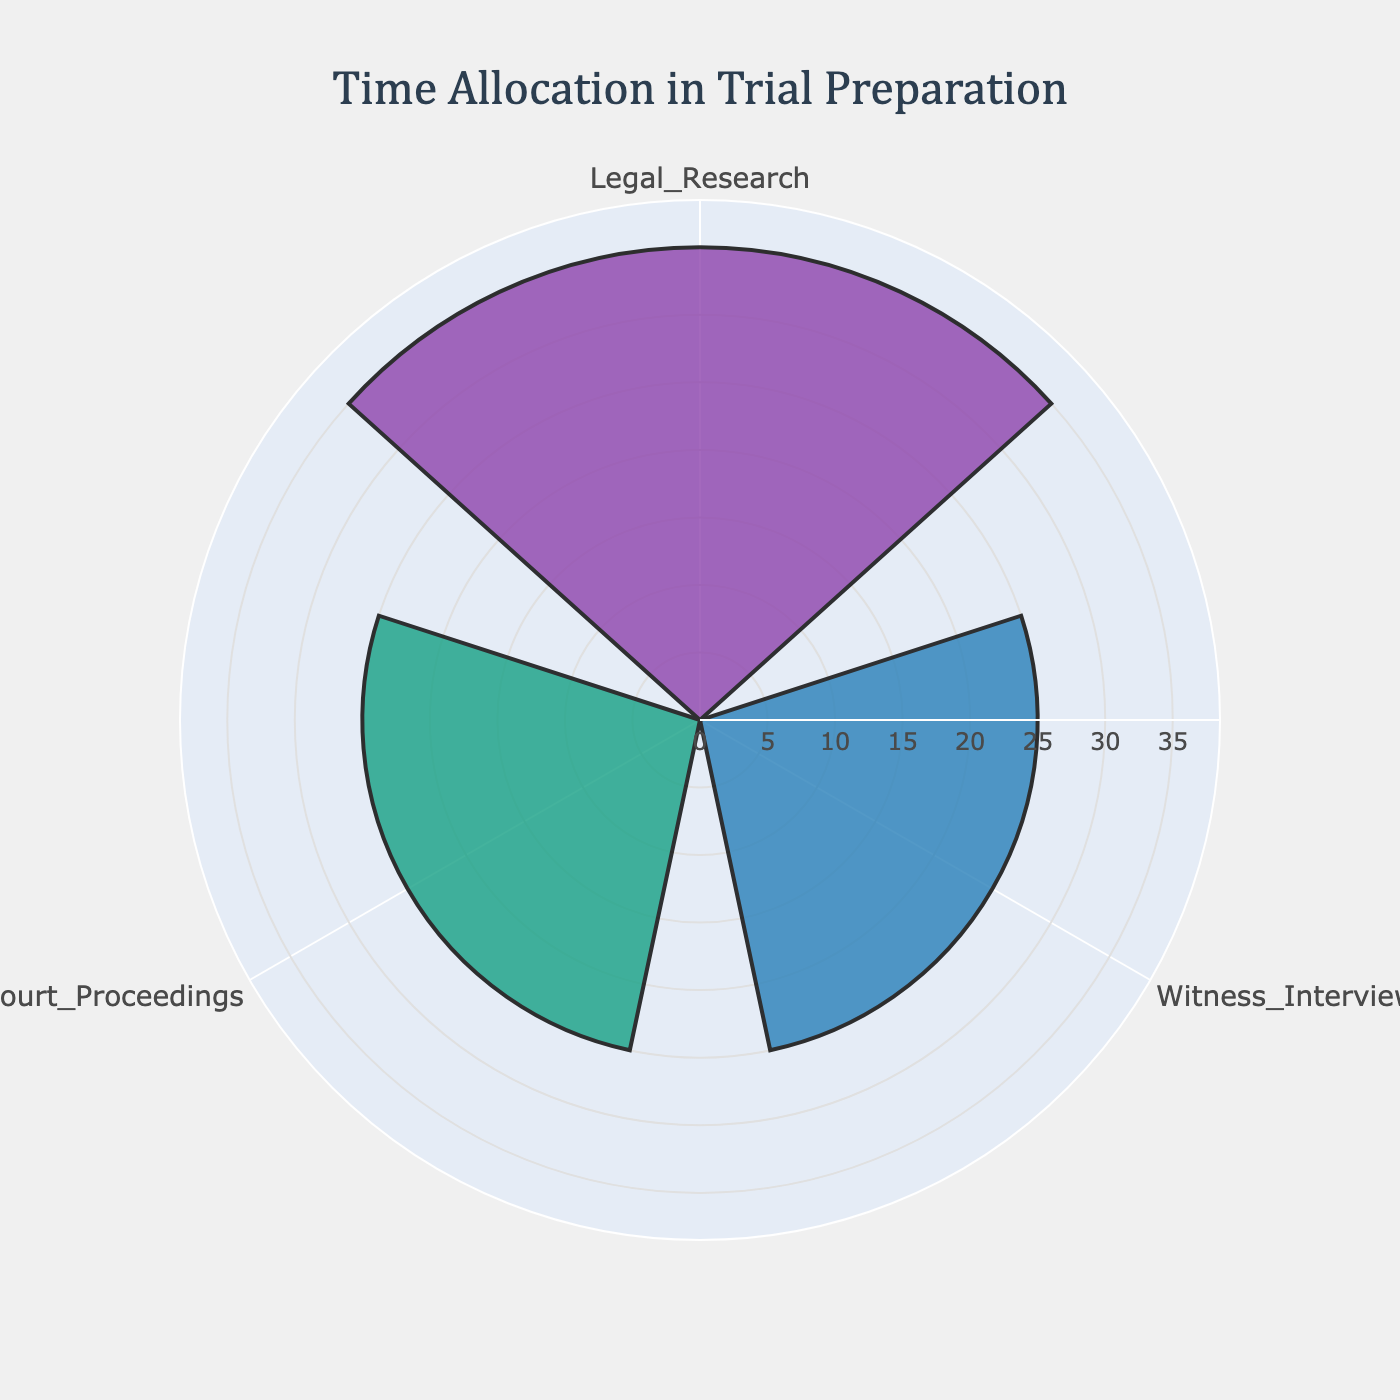What's the title of the chart? The title is usually displayed at the top of the chart to provide a brief summary of what the chart is about. The title on this chart reads "Time Allocation in Trial Preparation."
Answer: Time Allocation in Trial Preparation What are the three stages listed in the chart? The stages are labeled around the circular axis of the rose chart. They are "Legal Research," "Witness Interviews," and "Court Proceedings."
Answer: Legal Research, Witness Interviews, Court Proceedings Which stage has the highest percentage of time spent? By observing the lengths of the bars, the longest bar represents "Legal Research," indicating the highest percentage.
Answer: Legal Research How much percentage of time is dedicated to Witness Interviews? Refer to the specific bar labeled "Witness Interviews" and check its length. It corresponds to the value indicated, which is 25%.
Answer: 25% How much more time is spent on Court Proceedings compared to Document Preparation? Court Proceedings is shown in the chart with a percentage of 25%. Document Preparation is not included in the chart as it displays only the top 3 stages. From the data, Document Preparation has 15%. Calculate the difference by subtracting the two values.
Answer: 10% What is the combined percentage of time spent on Legal Research and Court Proceedings? Sum the percentages for Legal Research and Court Proceedings. They are 35% and 25%, respectively. Adding them gives the total time spent on both.
Answer: 60% How do the percentages for Legal Research and Witness Interviews compare? Compare the bars for Legal Research and Witness Interviews. Legal Research has 35%, while Witness Interviews has 25%. Clearly, Legal Research has a higher percentage by 10% than Witness Interviews.
Answer: Legal Research has 10% more What color represents Court Proceedings in the chart? Each bar in the rose chart is colored differently. The bar for Court Proceedings is marked in a specific color that can be identified visually. In this case, it is the third bar, colored green.
Answer: Green What percentage is the smallest among the three stages listed in the chart? The smallest percentage is determined by comparing the lengths of the bars. Among Legal Research (35%), Witness Interviews (25%), and Court Proceedings (25%), the smallest percentage is 25%, which applies to both Witness Interviews and Court Proceedings.
Answer: 25% Which two stages are represented by the same percentage in the chart? Look at the lengths of the bars and their corresponding percentages. Both Witness Interviews and Court Proceedings have the same length and percentage value of 25%.
Answer: Witness Interviews and Court Proceedings 